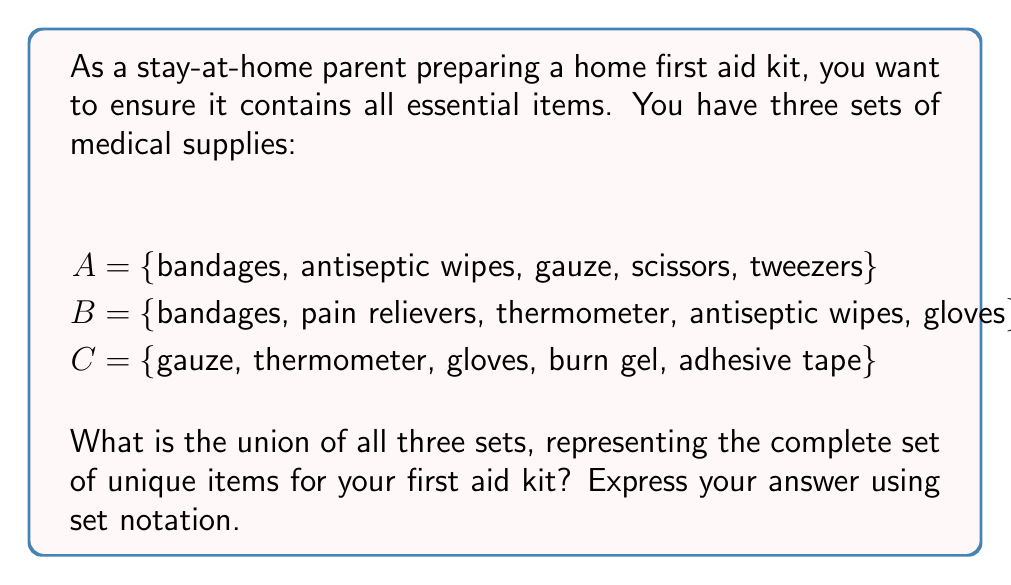Teach me how to tackle this problem. To solve this problem, we need to find the union of sets A, B, and C. The union of sets includes all unique elements from all sets involved. Let's follow these steps:

1. Identify all unique elements across the three sets:
   - bandages (in A and B)
   - antiseptic wipes (in A and B)
   - gauze (in A and C)
   - scissors (in A)
   - tweezers (in A)
   - pain relievers (in B)
   - thermometer (in B and C)
   - gloves (in B and C)
   - burn gel (in C)
   - adhesive tape (in C)

2. Create a new set that includes all these unique elements:
   $A \cup B \cup C = \{$ bandages, antiseptic wipes, gauze, scissors, tweezers, pain relievers, thermometer, gloves, burn gel, adhesive tape $\}$

3. Count the total number of unique items:
   $|A \cup B \cup C| = 10$

Therefore, the union of all three sets contains 10 unique items for the home first aid kit.
Answer: $A \cup B \cup C = \{$ bandages, antiseptic wipes, gauze, scissors, tweezers, pain relievers, thermometer, gloves, burn gel, adhesive tape $\}$ 